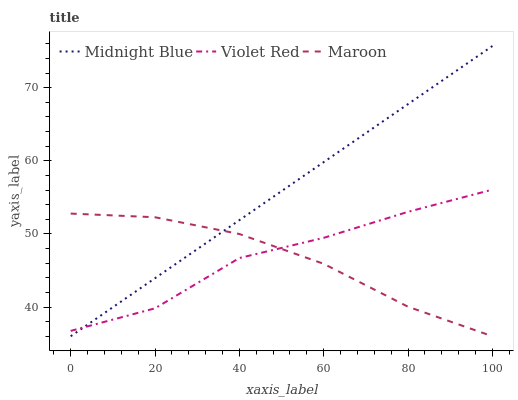Does Midnight Blue have the minimum area under the curve?
Answer yes or no. No. Does Maroon have the maximum area under the curve?
Answer yes or no. No. Is Maroon the smoothest?
Answer yes or no. No. Is Maroon the roughest?
Answer yes or no. No. Does Maroon have the highest value?
Answer yes or no. No. 